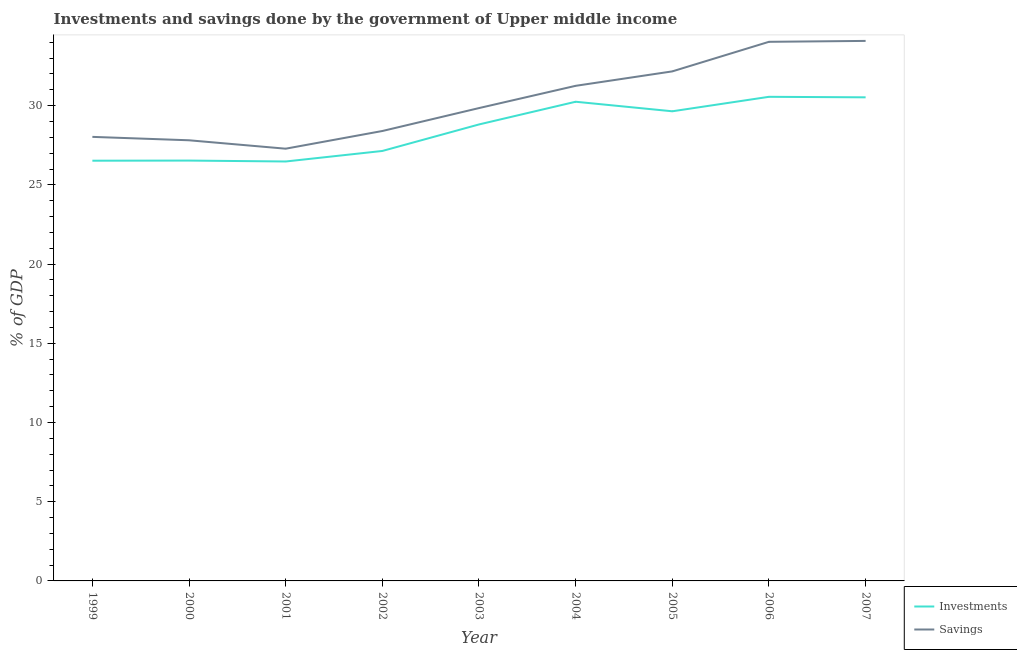How many different coloured lines are there?
Your answer should be compact. 2. Does the line corresponding to savings of government intersect with the line corresponding to investments of government?
Keep it short and to the point. No. Is the number of lines equal to the number of legend labels?
Ensure brevity in your answer.  Yes. What is the investments of government in 2001?
Your answer should be very brief. 26.48. Across all years, what is the maximum investments of government?
Provide a short and direct response. 30.56. Across all years, what is the minimum savings of government?
Offer a terse response. 27.28. In which year was the investments of government minimum?
Your answer should be compact. 2001. What is the total investments of government in the graph?
Offer a terse response. 256.48. What is the difference between the investments of government in 2000 and that in 2006?
Ensure brevity in your answer.  -4.03. What is the difference between the savings of government in 1999 and the investments of government in 2000?
Your answer should be compact. 1.5. What is the average investments of government per year?
Provide a short and direct response. 28.5. In the year 2001, what is the difference between the investments of government and savings of government?
Ensure brevity in your answer.  -0.81. What is the ratio of the savings of government in 2002 to that in 2007?
Ensure brevity in your answer.  0.83. What is the difference between the highest and the second highest savings of government?
Provide a succinct answer. 0.06. What is the difference between the highest and the lowest savings of government?
Your answer should be compact. 6.8. In how many years, is the investments of government greater than the average investments of government taken over all years?
Keep it short and to the point. 5. Is the investments of government strictly greater than the savings of government over the years?
Offer a terse response. No. Does the graph contain any zero values?
Give a very brief answer. No. Does the graph contain grids?
Ensure brevity in your answer.  No. How many legend labels are there?
Your answer should be compact. 2. What is the title of the graph?
Provide a succinct answer. Investments and savings done by the government of Upper middle income. Does "Highest 20% of population" appear as one of the legend labels in the graph?
Give a very brief answer. No. What is the label or title of the Y-axis?
Your response must be concise. % of GDP. What is the % of GDP in Investments in 1999?
Offer a terse response. 26.53. What is the % of GDP in Savings in 1999?
Keep it short and to the point. 28.03. What is the % of GDP in Investments in 2000?
Provide a succinct answer. 26.53. What is the % of GDP of Savings in 2000?
Ensure brevity in your answer.  27.82. What is the % of GDP in Investments in 2001?
Offer a very short reply. 26.48. What is the % of GDP in Savings in 2001?
Keep it short and to the point. 27.28. What is the % of GDP of Investments in 2002?
Your answer should be very brief. 27.14. What is the % of GDP in Savings in 2002?
Your response must be concise. 28.4. What is the % of GDP in Investments in 2003?
Ensure brevity in your answer.  28.82. What is the % of GDP in Savings in 2003?
Your answer should be very brief. 29.85. What is the % of GDP in Investments in 2004?
Your response must be concise. 30.25. What is the % of GDP in Savings in 2004?
Offer a very short reply. 31.25. What is the % of GDP of Investments in 2005?
Provide a short and direct response. 29.65. What is the % of GDP in Savings in 2005?
Your answer should be very brief. 32.16. What is the % of GDP in Investments in 2006?
Keep it short and to the point. 30.56. What is the % of GDP in Savings in 2006?
Offer a very short reply. 34.03. What is the % of GDP of Investments in 2007?
Your answer should be very brief. 30.53. What is the % of GDP of Savings in 2007?
Provide a succinct answer. 34.09. Across all years, what is the maximum % of GDP in Investments?
Provide a short and direct response. 30.56. Across all years, what is the maximum % of GDP in Savings?
Offer a terse response. 34.09. Across all years, what is the minimum % of GDP of Investments?
Offer a very short reply. 26.48. Across all years, what is the minimum % of GDP of Savings?
Keep it short and to the point. 27.28. What is the total % of GDP in Investments in the graph?
Provide a short and direct response. 256.48. What is the total % of GDP of Savings in the graph?
Provide a succinct answer. 272.92. What is the difference between the % of GDP of Investments in 1999 and that in 2000?
Offer a terse response. -0.01. What is the difference between the % of GDP of Savings in 1999 and that in 2000?
Ensure brevity in your answer.  0.21. What is the difference between the % of GDP of Investments in 1999 and that in 2001?
Your response must be concise. 0.05. What is the difference between the % of GDP of Savings in 1999 and that in 2001?
Your answer should be compact. 0.75. What is the difference between the % of GDP of Investments in 1999 and that in 2002?
Offer a terse response. -0.61. What is the difference between the % of GDP in Savings in 1999 and that in 2002?
Your answer should be very brief. -0.37. What is the difference between the % of GDP of Investments in 1999 and that in 2003?
Your answer should be compact. -2.29. What is the difference between the % of GDP in Savings in 1999 and that in 2003?
Give a very brief answer. -1.82. What is the difference between the % of GDP of Investments in 1999 and that in 2004?
Make the answer very short. -3.72. What is the difference between the % of GDP of Savings in 1999 and that in 2004?
Offer a very short reply. -3.22. What is the difference between the % of GDP of Investments in 1999 and that in 2005?
Provide a short and direct response. -3.12. What is the difference between the % of GDP in Savings in 1999 and that in 2005?
Make the answer very short. -4.13. What is the difference between the % of GDP in Investments in 1999 and that in 2006?
Provide a succinct answer. -4.03. What is the difference between the % of GDP of Savings in 1999 and that in 2006?
Your answer should be compact. -6. What is the difference between the % of GDP of Investments in 1999 and that in 2007?
Your response must be concise. -4. What is the difference between the % of GDP in Savings in 1999 and that in 2007?
Your response must be concise. -6.06. What is the difference between the % of GDP of Investments in 2000 and that in 2001?
Provide a short and direct response. 0.06. What is the difference between the % of GDP of Savings in 2000 and that in 2001?
Make the answer very short. 0.53. What is the difference between the % of GDP in Investments in 2000 and that in 2002?
Provide a short and direct response. -0.61. What is the difference between the % of GDP of Savings in 2000 and that in 2002?
Your answer should be very brief. -0.59. What is the difference between the % of GDP in Investments in 2000 and that in 2003?
Ensure brevity in your answer.  -2.28. What is the difference between the % of GDP of Savings in 2000 and that in 2003?
Your answer should be compact. -2.03. What is the difference between the % of GDP in Investments in 2000 and that in 2004?
Provide a succinct answer. -3.71. What is the difference between the % of GDP of Savings in 2000 and that in 2004?
Make the answer very short. -3.44. What is the difference between the % of GDP in Investments in 2000 and that in 2005?
Your answer should be compact. -3.11. What is the difference between the % of GDP in Savings in 2000 and that in 2005?
Ensure brevity in your answer.  -4.35. What is the difference between the % of GDP of Investments in 2000 and that in 2006?
Give a very brief answer. -4.03. What is the difference between the % of GDP in Savings in 2000 and that in 2006?
Your response must be concise. -6.22. What is the difference between the % of GDP of Investments in 2000 and that in 2007?
Offer a terse response. -3.99. What is the difference between the % of GDP in Savings in 2000 and that in 2007?
Offer a very short reply. -6.27. What is the difference between the % of GDP in Investments in 2001 and that in 2002?
Your response must be concise. -0.66. What is the difference between the % of GDP in Savings in 2001 and that in 2002?
Provide a succinct answer. -1.12. What is the difference between the % of GDP in Investments in 2001 and that in 2003?
Your answer should be compact. -2.34. What is the difference between the % of GDP of Savings in 2001 and that in 2003?
Your response must be concise. -2.56. What is the difference between the % of GDP of Investments in 2001 and that in 2004?
Your answer should be compact. -3.77. What is the difference between the % of GDP of Savings in 2001 and that in 2004?
Offer a very short reply. -3.97. What is the difference between the % of GDP of Investments in 2001 and that in 2005?
Offer a very short reply. -3.17. What is the difference between the % of GDP in Savings in 2001 and that in 2005?
Keep it short and to the point. -4.88. What is the difference between the % of GDP in Investments in 2001 and that in 2006?
Give a very brief answer. -4.08. What is the difference between the % of GDP of Savings in 2001 and that in 2006?
Offer a very short reply. -6.75. What is the difference between the % of GDP in Investments in 2001 and that in 2007?
Your response must be concise. -4.05. What is the difference between the % of GDP of Savings in 2001 and that in 2007?
Your response must be concise. -6.8. What is the difference between the % of GDP of Investments in 2002 and that in 2003?
Give a very brief answer. -1.67. What is the difference between the % of GDP of Savings in 2002 and that in 2003?
Keep it short and to the point. -1.45. What is the difference between the % of GDP of Investments in 2002 and that in 2004?
Make the answer very short. -3.11. What is the difference between the % of GDP of Savings in 2002 and that in 2004?
Your response must be concise. -2.85. What is the difference between the % of GDP in Investments in 2002 and that in 2005?
Keep it short and to the point. -2.5. What is the difference between the % of GDP of Savings in 2002 and that in 2005?
Your answer should be compact. -3.76. What is the difference between the % of GDP in Investments in 2002 and that in 2006?
Ensure brevity in your answer.  -3.42. What is the difference between the % of GDP of Savings in 2002 and that in 2006?
Offer a very short reply. -5.63. What is the difference between the % of GDP in Investments in 2002 and that in 2007?
Your response must be concise. -3.39. What is the difference between the % of GDP of Savings in 2002 and that in 2007?
Give a very brief answer. -5.69. What is the difference between the % of GDP in Investments in 2003 and that in 2004?
Your response must be concise. -1.43. What is the difference between the % of GDP of Savings in 2003 and that in 2004?
Provide a succinct answer. -1.4. What is the difference between the % of GDP of Investments in 2003 and that in 2005?
Provide a short and direct response. -0.83. What is the difference between the % of GDP in Savings in 2003 and that in 2005?
Make the answer very short. -2.32. What is the difference between the % of GDP in Investments in 2003 and that in 2006?
Your response must be concise. -1.74. What is the difference between the % of GDP in Savings in 2003 and that in 2006?
Provide a short and direct response. -4.18. What is the difference between the % of GDP in Investments in 2003 and that in 2007?
Your answer should be compact. -1.71. What is the difference between the % of GDP in Savings in 2003 and that in 2007?
Keep it short and to the point. -4.24. What is the difference between the % of GDP in Investments in 2004 and that in 2005?
Make the answer very short. 0.6. What is the difference between the % of GDP of Savings in 2004 and that in 2005?
Provide a short and direct response. -0.91. What is the difference between the % of GDP of Investments in 2004 and that in 2006?
Your response must be concise. -0.31. What is the difference between the % of GDP of Savings in 2004 and that in 2006?
Your response must be concise. -2.78. What is the difference between the % of GDP of Investments in 2004 and that in 2007?
Provide a succinct answer. -0.28. What is the difference between the % of GDP in Savings in 2004 and that in 2007?
Keep it short and to the point. -2.84. What is the difference between the % of GDP in Investments in 2005 and that in 2006?
Ensure brevity in your answer.  -0.91. What is the difference between the % of GDP of Savings in 2005 and that in 2006?
Your response must be concise. -1.87. What is the difference between the % of GDP of Investments in 2005 and that in 2007?
Provide a succinct answer. -0.88. What is the difference between the % of GDP of Savings in 2005 and that in 2007?
Ensure brevity in your answer.  -1.92. What is the difference between the % of GDP in Investments in 2006 and that in 2007?
Give a very brief answer. 0.03. What is the difference between the % of GDP of Savings in 2006 and that in 2007?
Offer a terse response. -0.06. What is the difference between the % of GDP of Investments in 1999 and the % of GDP of Savings in 2000?
Give a very brief answer. -1.29. What is the difference between the % of GDP in Investments in 1999 and the % of GDP in Savings in 2001?
Your response must be concise. -0.76. What is the difference between the % of GDP of Investments in 1999 and the % of GDP of Savings in 2002?
Provide a short and direct response. -1.87. What is the difference between the % of GDP in Investments in 1999 and the % of GDP in Savings in 2003?
Make the answer very short. -3.32. What is the difference between the % of GDP of Investments in 1999 and the % of GDP of Savings in 2004?
Your answer should be compact. -4.73. What is the difference between the % of GDP in Investments in 1999 and the % of GDP in Savings in 2005?
Ensure brevity in your answer.  -5.64. What is the difference between the % of GDP of Investments in 1999 and the % of GDP of Savings in 2006?
Ensure brevity in your answer.  -7.51. What is the difference between the % of GDP of Investments in 1999 and the % of GDP of Savings in 2007?
Make the answer very short. -7.56. What is the difference between the % of GDP in Investments in 2000 and the % of GDP in Savings in 2001?
Your answer should be compact. -0.75. What is the difference between the % of GDP in Investments in 2000 and the % of GDP in Savings in 2002?
Provide a short and direct response. -1.87. What is the difference between the % of GDP in Investments in 2000 and the % of GDP in Savings in 2003?
Your answer should be compact. -3.31. What is the difference between the % of GDP in Investments in 2000 and the % of GDP in Savings in 2004?
Make the answer very short. -4.72. What is the difference between the % of GDP of Investments in 2000 and the % of GDP of Savings in 2005?
Provide a short and direct response. -5.63. What is the difference between the % of GDP in Investments in 2000 and the % of GDP in Savings in 2006?
Provide a succinct answer. -7.5. What is the difference between the % of GDP in Investments in 2000 and the % of GDP in Savings in 2007?
Make the answer very short. -7.55. What is the difference between the % of GDP of Investments in 2001 and the % of GDP of Savings in 2002?
Make the answer very short. -1.92. What is the difference between the % of GDP of Investments in 2001 and the % of GDP of Savings in 2003?
Provide a short and direct response. -3.37. What is the difference between the % of GDP of Investments in 2001 and the % of GDP of Savings in 2004?
Provide a short and direct response. -4.78. What is the difference between the % of GDP in Investments in 2001 and the % of GDP in Savings in 2005?
Make the answer very short. -5.69. What is the difference between the % of GDP of Investments in 2001 and the % of GDP of Savings in 2006?
Offer a terse response. -7.55. What is the difference between the % of GDP of Investments in 2001 and the % of GDP of Savings in 2007?
Make the answer very short. -7.61. What is the difference between the % of GDP in Investments in 2002 and the % of GDP in Savings in 2003?
Give a very brief answer. -2.71. What is the difference between the % of GDP in Investments in 2002 and the % of GDP in Savings in 2004?
Provide a short and direct response. -4.11. What is the difference between the % of GDP in Investments in 2002 and the % of GDP in Savings in 2005?
Provide a short and direct response. -5.02. What is the difference between the % of GDP in Investments in 2002 and the % of GDP in Savings in 2006?
Ensure brevity in your answer.  -6.89. What is the difference between the % of GDP in Investments in 2002 and the % of GDP in Savings in 2007?
Make the answer very short. -6.95. What is the difference between the % of GDP of Investments in 2003 and the % of GDP of Savings in 2004?
Keep it short and to the point. -2.44. What is the difference between the % of GDP of Investments in 2003 and the % of GDP of Savings in 2005?
Make the answer very short. -3.35. What is the difference between the % of GDP of Investments in 2003 and the % of GDP of Savings in 2006?
Offer a very short reply. -5.22. What is the difference between the % of GDP in Investments in 2003 and the % of GDP in Savings in 2007?
Give a very brief answer. -5.27. What is the difference between the % of GDP of Investments in 2004 and the % of GDP of Savings in 2005?
Offer a terse response. -1.92. What is the difference between the % of GDP in Investments in 2004 and the % of GDP in Savings in 2006?
Make the answer very short. -3.78. What is the difference between the % of GDP of Investments in 2004 and the % of GDP of Savings in 2007?
Give a very brief answer. -3.84. What is the difference between the % of GDP of Investments in 2005 and the % of GDP of Savings in 2006?
Make the answer very short. -4.39. What is the difference between the % of GDP of Investments in 2005 and the % of GDP of Savings in 2007?
Your response must be concise. -4.44. What is the difference between the % of GDP in Investments in 2006 and the % of GDP in Savings in 2007?
Give a very brief answer. -3.53. What is the average % of GDP in Investments per year?
Ensure brevity in your answer.  28.5. What is the average % of GDP of Savings per year?
Your response must be concise. 30.32. In the year 1999, what is the difference between the % of GDP of Investments and % of GDP of Savings?
Provide a succinct answer. -1.5. In the year 2000, what is the difference between the % of GDP of Investments and % of GDP of Savings?
Your answer should be very brief. -1.28. In the year 2001, what is the difference between the % of GDP in Investments and % of GDP in Savings?
Ensure brevity in your answer.  -0.81. In the year 2002, what is the difference between the % of GDP in Investments and % of GDP in Savings?
Your response must be concise. -1.26. In the year 2003, what is the difference between the % of GDP of Investments and % of GDP of Savings?
Offer a very short reply. -1.03. In the year 2004, what is the difference between the % of GDP of Investments and % of GDP of Savings?
Your response must be concise. -1.01. In the year 2005, what is the difference between the % of GDP of Investments and % of GDP of Savings?
Your answer should be very brief. -2.52. In the year 2006, what is the difference between the % of GDP of Investments and % of GDP of Savings?
Offer a terse response. -3.47. In the year 2007, what is the difference between the % of GDP of Investments and % of GDP of Savings?
Offer a very short reply. -3.56. What is the ratio of the % of GDP of Savings in 1999 to that in 2000?
Your answer should be very brief. 1.01. What is the ratio of the % of GDP in Savings in 1999 to that in 2001?
Offer a very short reply. 1.03. What is the ratio of the % of GDP of Investments in 1999 to that in 2002?
Make the answer very short. 0.98. What is the ratio of the % of GDP in Savings in 1999 to that in 2002?
Provide a succinct answer. 0.99. What is the ratio of the % of GDP of Investments in 1999 to that in 2003?
Your answer should be very brief. 0.92. What is the ratio of the % of GDP in Savings in 1999 to that in 2003?
Your response must be concise. 0.94. What is the ratio of the % of GDP of Investments in 1999 to that in 2004?
Ensure brevity in your answer.  0.88. What is the ratio of the % of GDP of Savings in 1999 to that in 2004?
Offer a very short reply. 0.9. What is the ratio of the % of GDP of Investments in 1999 to that in 2005?
Your answer should be very brief. 0.89. What is the ratio of the % of GDP of Savings in 1999 to that in 2005?
Keep it short and to the point. 0.87. What is the ratio of the % of GDP of Investments in 1999 to that in 2006?
Keep it short and to the point. 0.87. What is the ratio of the % of GDP of Savings in 1999 to that in 2006?
Your answer should be compact. 0.82. What is the ratio of the % of GDP of Investments in 1999 to that in 2007?
Provide a succinct answer. 0.87. What is the ratio of the % of GDP of Savings in 1999 to that in 2007?
Your answer should be very brief. 0.82. What is the ratio of the % of GDP in Savings in 2000 to that in 2001?
Your answer should be compact. 1.02. What is the ratio of the % of GDP of Investments in 2000 to that in 2002?
Offer a terse response. 0.98. What is the ratio of the % of GDP in Savings in 2000 to that in 2002?
Your answer should be compact. 0.98. What is the ratio of the % of GDP in Investments in 2000 to that in 2003?
Make the answer very short. 0.92. What is the ratio of the % of GDP in Savings in 2000 to that in 2003?
Provide a short and direct response. 0.93. What is the ratio of the % of GDP in Investments in 2000 to that in 2004?
Provide a succinct answer. 0.88. What is the ratio of the % of GDP in Savings in 2000 to that in 2004?
Your response must be concise. 0.89. What is the ratio of the % of GDP of Investments in 2000 to that in 2005?
Ensure brevity in your answer.  0.9. What is the ratio of the % of GDP in Savings in 2000 to that in 2005?
Provide a short and direct response. 0.86. What is the ratio of the % of GDP in Investments in 2000 to that in 2006?
Offer a very short reply. 0.87. What is the ratio of the % of GDP in Savings in 2000 to that in 2006?
Ensure brevity in your answer.  0.82. What is the ratio of the % of GDP in Investments in 2000 to that in 2007?
Provide a short and direct response. 0.87. What is the ratio of the % of GDP of Savings in 2000 to that in 2007?
Your answer should be compact. 0.82. What is the ratio of the % of GDP of Investments in 2001 to that in 2002?
Keep it short and to the point. 0.98. What is the ratio of the % of GDP in Savings in 2001 to that in 2002?
Provide a succinct answer. 0.96. What is the ratio of the % of GDP in Investments in 2001 to that in 2003?
Keep it short and to the point. 0.92. What is the ratio of the % of GDP of Savings in 2001 to that in 2003?
Make the answer very short. 0.91. What is the ratio of the % of GDP in Investments in 2001 to that in 2004?
Your answer should be compact. 0.88. What is the ratio of the % of GDP in Savings in 2001 to that in 2004?
Provide a short and direct response. 0.87. What is the ratio of the % of GDP in Investments in 2001 to that in 2005?
Provide a short and direct response. 0.89. What is the ratio of the % of GDP in Savings in 2001 to that in 2005?
Offer a terse response. 0.85. What is the ratio of the % of GDP in Investments in 2001 to that in 2006?
Ensure brevity in your answer.  0.87. What is the ratio of the % of GDP of Savings in 2001 to that in 2006?
Give a very brief answer. 0.8. What is the ratio of the % of GDP of Investments in 2001 to that in 2007?
Ensure brevity in your answer.  0.87. What is the ratio of the % of GDP of Savings in 2001 to that in 2007?
Keep it short and to the point. 0.8. What is the ratio of the % of GDP of Investments in 2002 to that in 2003?
Your answer should be very brief. 0.94. What is the ratio of the % of GDP of Savings in 2002 to that in 2003?
Your answer should be compact. 0.95. What is the ratio of the % of GDP of Investments in 2002 to that in 2004?
Provide a short and direct response. 0.9. What is the ratio of the % of GDP of Savings in 2002 to that in 2004?
Ensure brevity in your answer.  0.91. What is the ratio of the % of GDP in Investments in 2002 to that in 2005?
Your answer should be very brief. 0.92. What is the ratio of the % of GDP in Savings in 2002 to that in 2005?
Ensure brevity in your answer.  0.88. What is the ratio of the % of GDP in Investments in 2002 to that in 2006?
Provide a succinct answer. 0.89. What is the ratio of the % of GDP in Savings in 2002 to that in 2006?
Ensure brevity in your answer.  0.83. What is the ratio of the % of GDP in Investments in 2002 to that in 2007?
Provide a short and direct response. 0.89. What is the ratio of the % of GDP in Savings in 2002 to that in 2007?
Offer a terse response. 0.83. What is the ratio of the % of GDP of Investments in 2003 to that in 2004?
Give a very brief answer. 0.95. What is the ratio of the % of GDP of Savings in 2003 to that in 2004?
Your answer should be compact. 0.95. What is the ratio of the % of GDP in Savings in 2003 to that in 2005?
Provide a short and direct response. 0.93. What is the ratio of the % of GDP of Investments in 2003 to that in 2006?
Your response must be concise. 0.94. What is the ratio of the % of GDP in Savings in 2003 to that in 2006?
Ensure brevity in your answer.  0.88. What is the ratio of the % of GDP in Investments in 2003 to that in 2007?
Offer a very short reply. 0.94. What is the ratio of the % of GDP of Savings in 2003 to that in 2007?
Your answer should be compact. 0.88. What is the ratio of the % of GDP of Investments in 2004 to that in 2005?
Your answer should be compact. 1.02. What is the ratio of the % of GDP in Savings in 2004 to that in 2005?
Offer a very short reply. 0.97. What is the ratio of the % of GDP in Investments in 2004 to that in 2006?
Keep it short and to the point. 0.99. What is the ratio of the % of GDP of Savings in 2004 to that in 2006?
Provide a succinct answer. 0.92. What is the ratio of the % of GDP in Investments in 2004 to that in 2007?
Your answer should be compact. 0.99. What is the ratio of the % of GDP in Savings in 2004 to that in 2007?
Make the answer very short. 0.92. What is the ratio of the % of GDP of Investments in 2005 to that in 2006?
Offer a very short reply. 0.97. What is the ratio of the % of GDP in Savings in 2005 to that in 2006?
Your answer should be very brief. 0.95. What is the ratio of the % of GDP of Investments in 2005 to that in 2007?
Ensure brevity in your answer.  0.97. What is the ratio of the % of GDP of Savings in 2005 to that in 2007?
Offer a very short reply. 0.94. What is the difference between the highest and the second highest % of GDP of Investments?
Make the answer very short. 0.03. What is the difference between the highest and the second highest % of GDP in Savings?
Provide a short and direct response. 0.06. What is the difference between the highest and the lowest % of GDP in Investments?
Your response must be concise. 4.08. What is the difference between the highest and the lowest % of GDP of Savings?
Your answer should be compact. 6.8. 